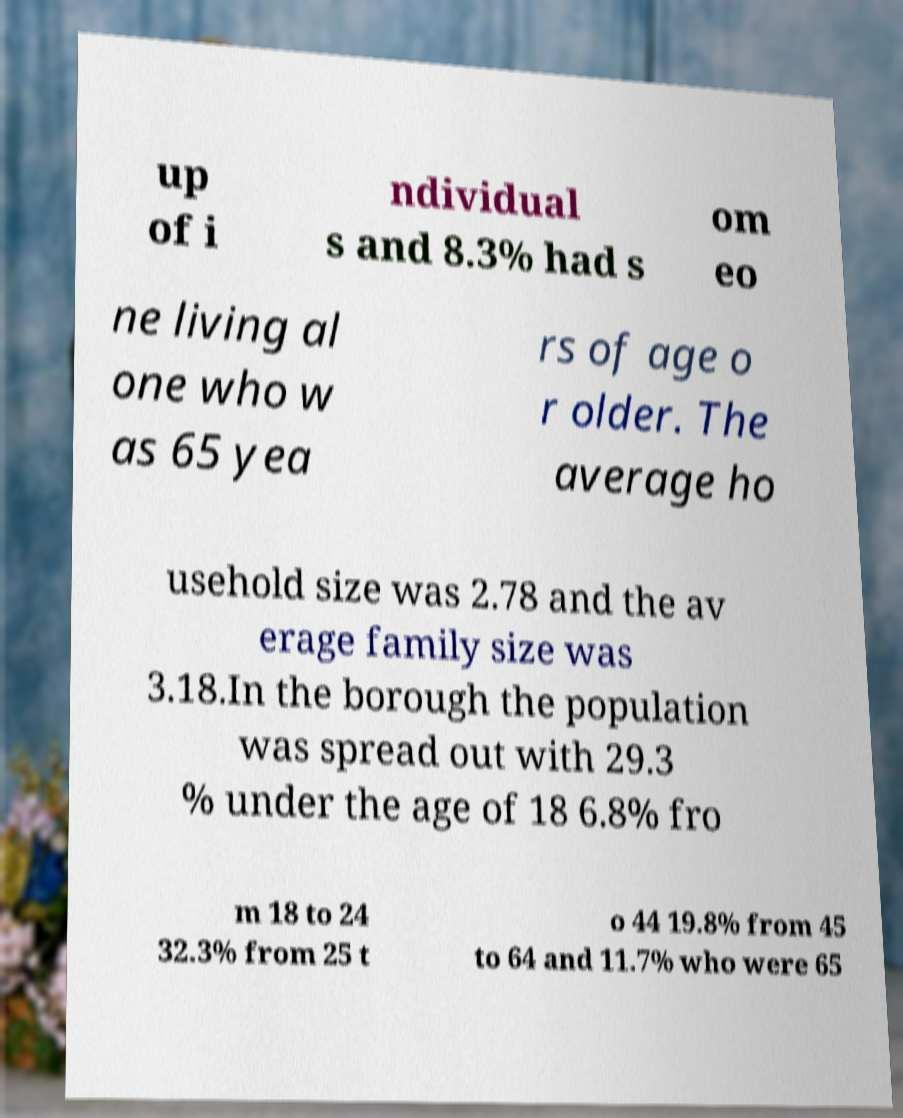What messages or text are displayed in this image? I need them in a readable, typed format. up of i ndividual s and 8.3% had s om eo ne living al one who w as 65 yea rs of age o r older. The average ho usehold size was 2.78 and the av erage family size was 3.18.In the borough the population was spread out with 29.3 % under the age of 18 6.8% fro m 18 to 24 32.3% from 25 t o 44 19.8% from 45 to 64 and 11.7% who were 65 